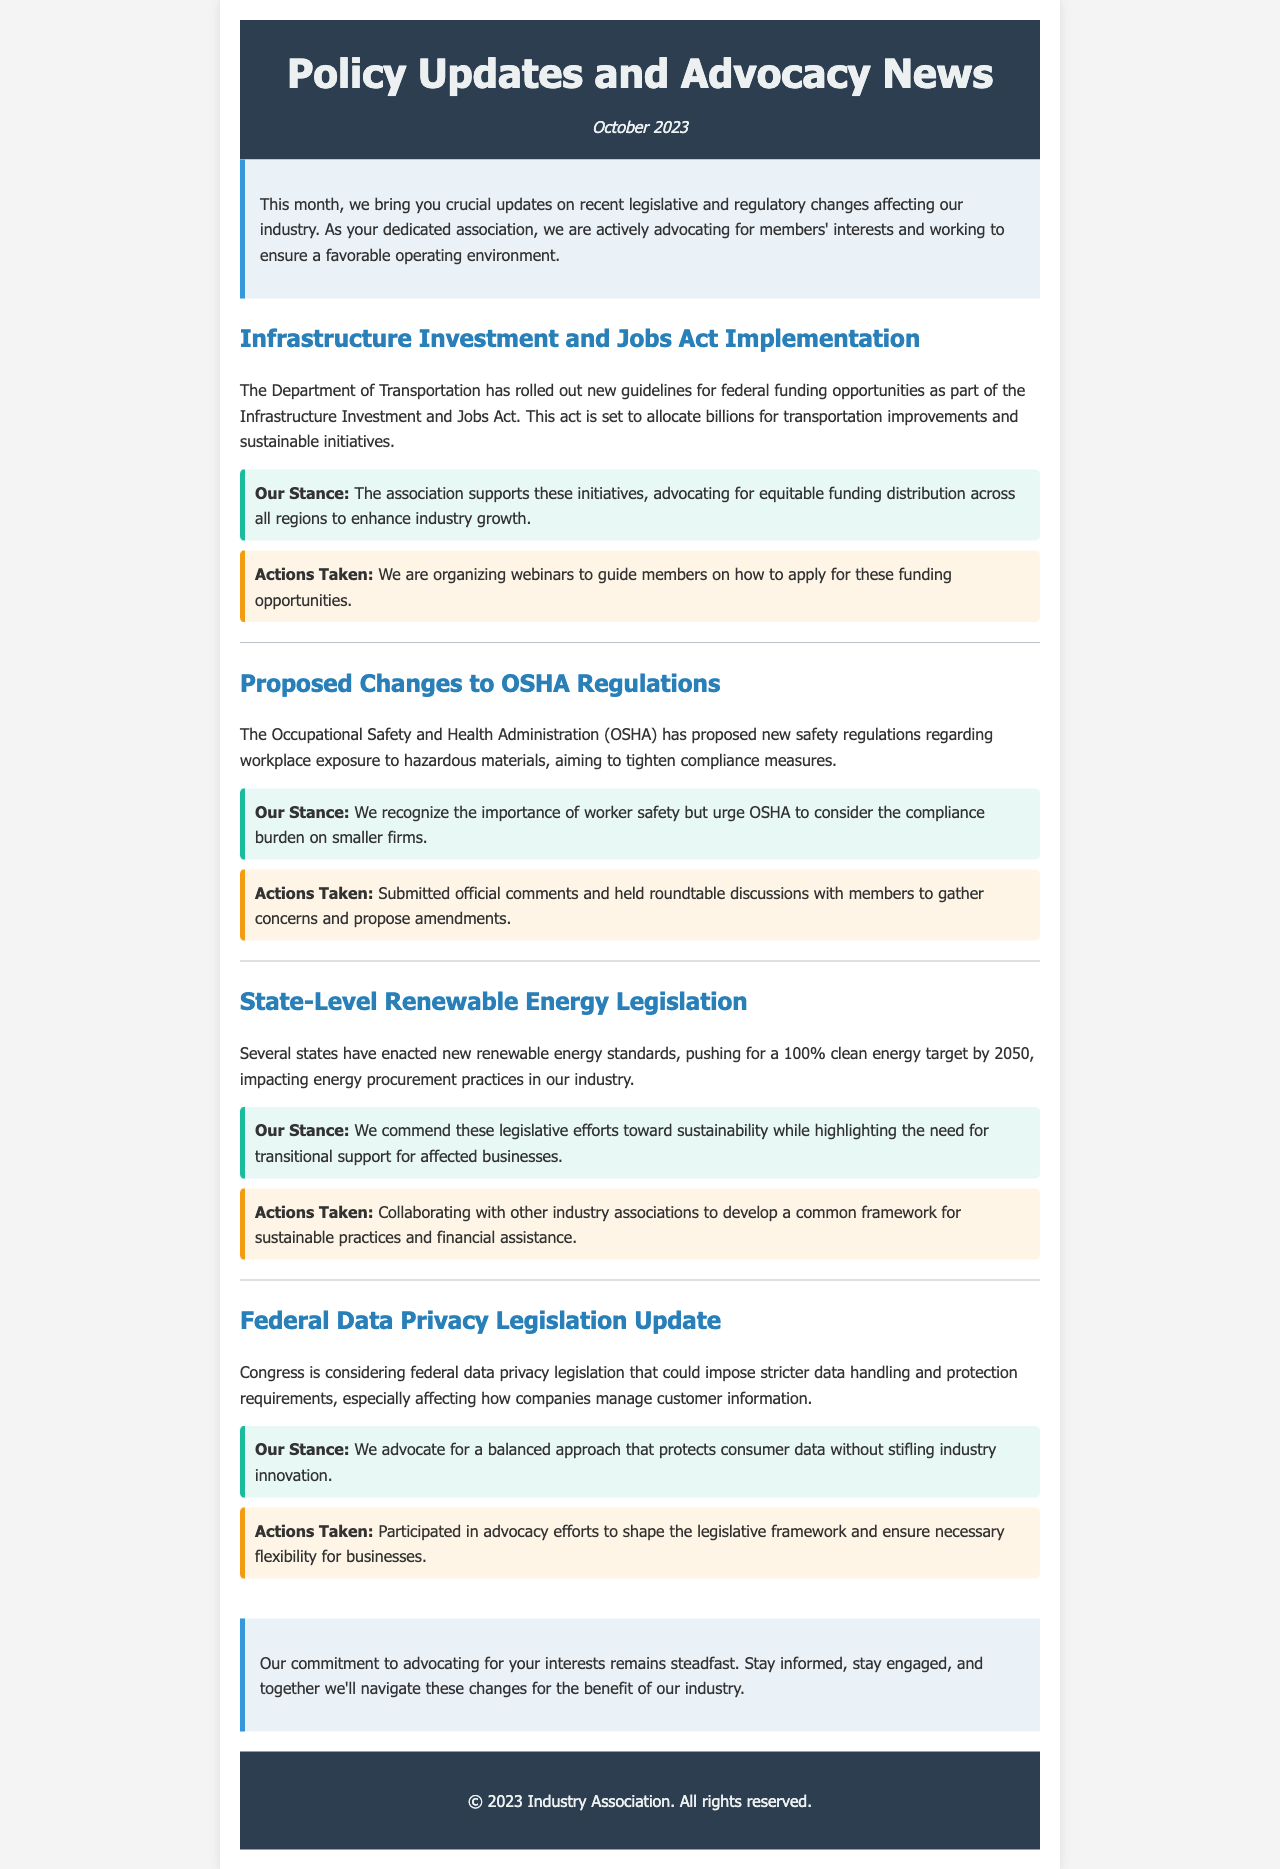What is the title of the newsletter? The title of the newsletter is prominently displayed at the top of the document.
Answer: Policy Updates and Advocacy News When was the newsletter published? The publication date is listed under the title in the header section of the newsletter.
Answer: October 2023 What is the main topic covered in the first update? The first update pertains to the implementation of federal funding opportunities as part of a specific act mentioned in the update.
Answer: Infrastructure Investment and Jobs Act Implementation What does the association urge OSHA to consider? This information is provided in the second update regarding the proposed changes to safety regulations.
Answer: Compliance burden on smaller firms What is the clean energy target year set by several states? The document specifies the target year related to renewable energy legislation discussed in the third update.
Answer: 2050 What actions has the association taken regarding workplace safety regulations? The actions taken are outlined in relation to the proposed changes by OSHA in the second update.
Answer: Submitted official comments and held roundtable discussions What is the association's stance on federal data privacy legislation? The stance is detailed in the update about federal data privacy and highlights the association’s concern.
Answer: Balanced approach How is the association supporting members in applying for funding opportunities? This is mentioned in the actions taken regarding the first update of the newsletter.
Answer: Organizing webinars What type of legislation is Congress considering? This information is detailed in the fourth update focusing on data protection.
Answer: Federal data privacy legislation What does the association recognize regarding renewable energy standards? The stance provided in the third update mentions this recognition.
Answer: Importance of sustainability 